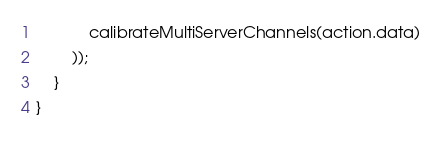Convert code to text. <code><loc_0><loc_0><loc_500><loc_500><_JavaScript_>			calibrateMultiServerChannels(action.data)
		));
	}
}
</code> 